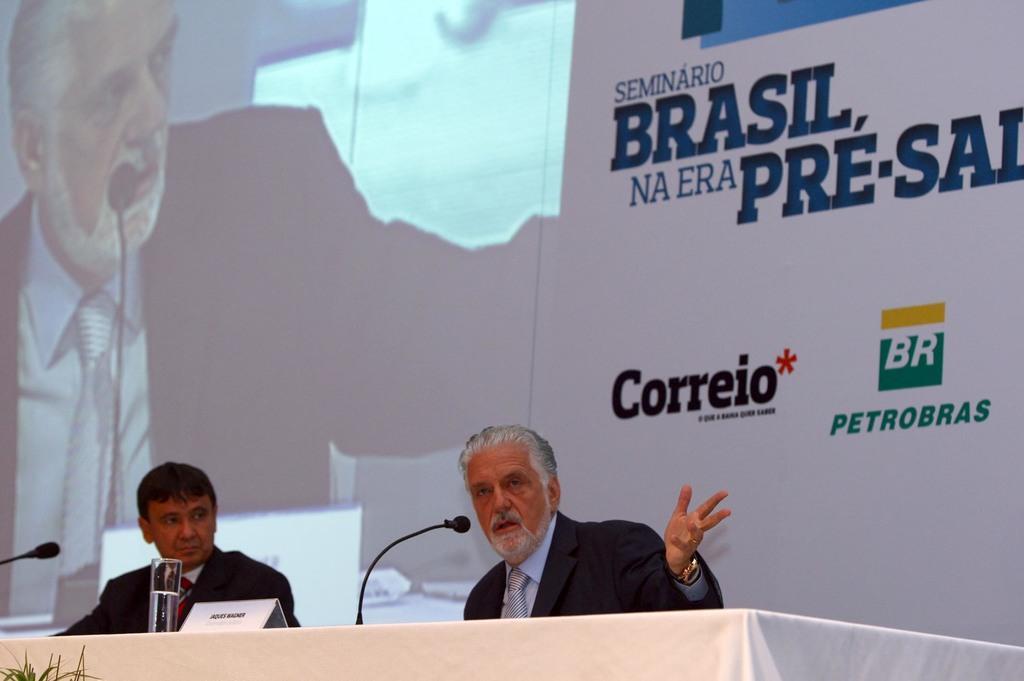How would you summarize this image in a sentence or two? At the bottom of the image we can see a table, on the table we can see a microphones and glass. Behind the table two persons are sitting. Behind them we can see a banner and screen. In the bottom left corner of the image we can see a plant. 